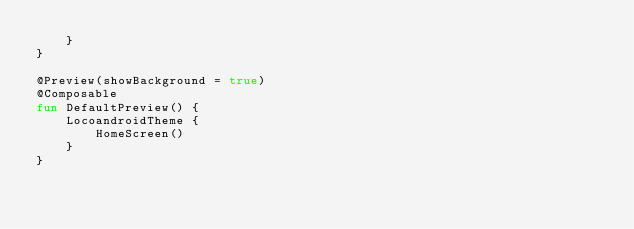Convert code to text. <code><loc_0><loc_0><loc_500><loc_500><_Kotlin_>    }
}

@Preview(showBackground = true)
@Composable
fun DefaultPreview() {
    LocoandroidTheme {
        HomeScreen()
    }
}</code> 